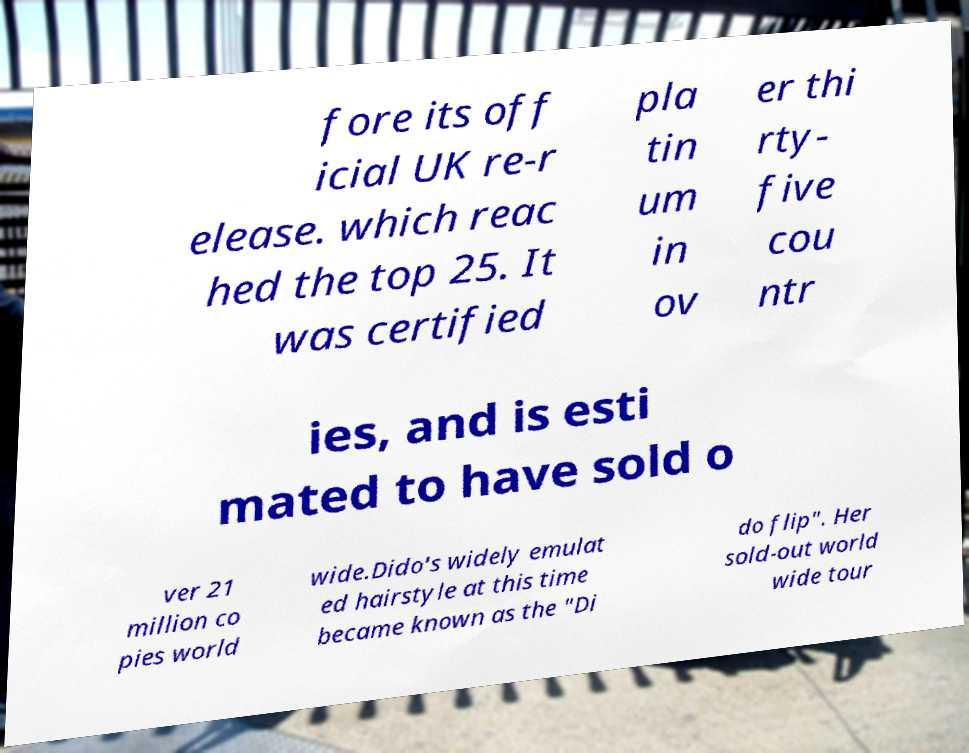What messages or text are displayed in this image? I need them in a readable, typed format. fore its off icial UK re-r elease. which reac hed the top 25. It was certified pla tin um in ov er thi rty- five cou ntr ies, and is esti mated to have sold o ver 21 million co pies world wide.Dido's widely emulat ed hairstyle at this time became known as the "Di do flip". Her sold-out world wide tour 